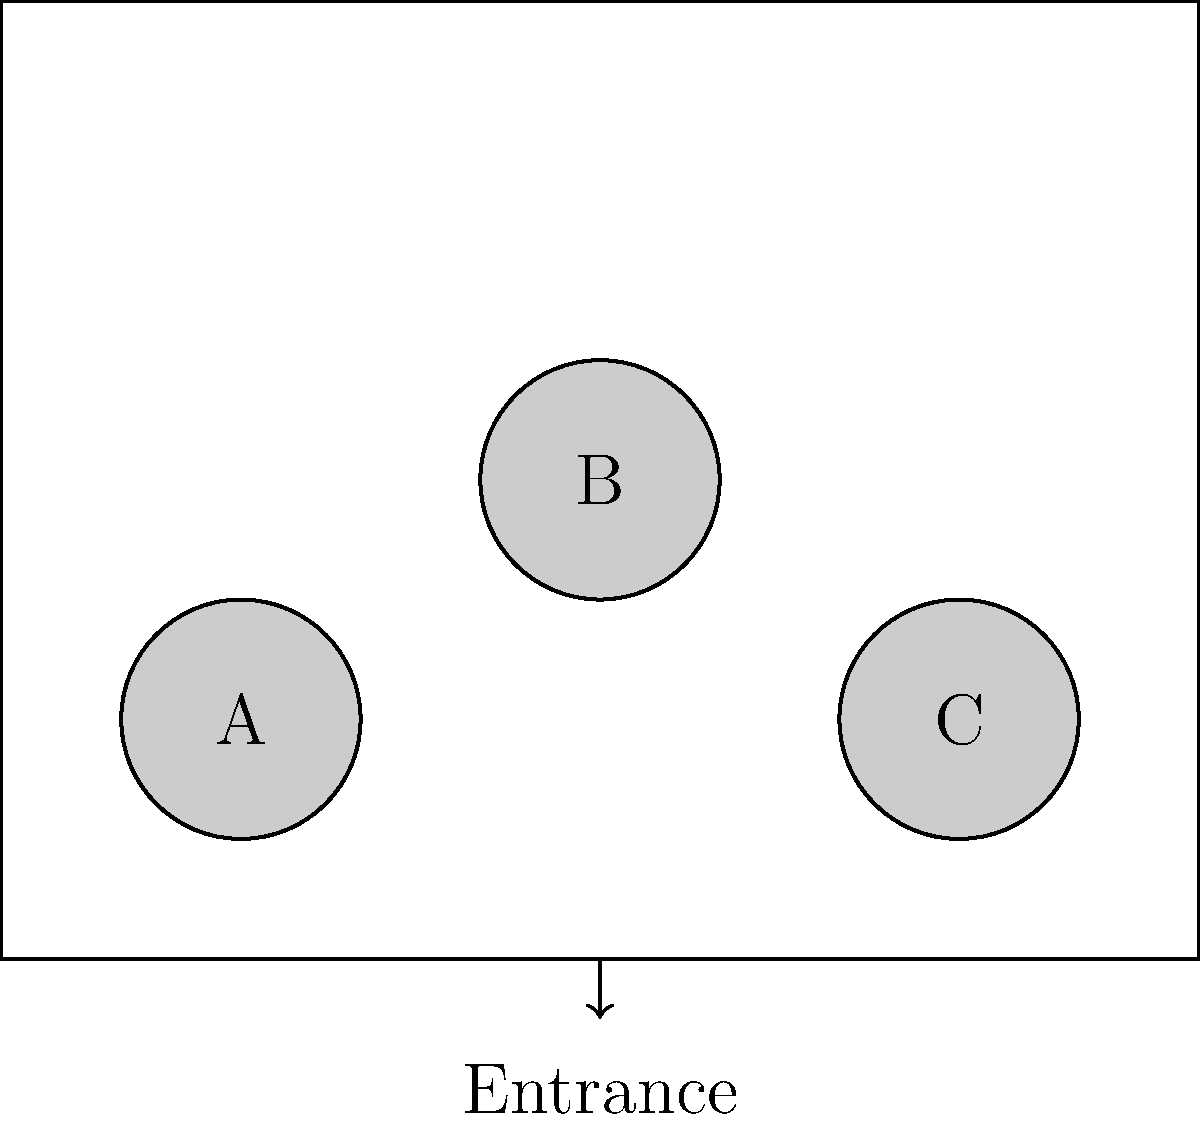You're organizing a community gathering in a rectangular room with three circular tables (A, B, and C) as shown in the floor plan. Each table can seat 8 people. If you want to maximize interaction between different groups and minimize walking distance from the entrance, which table should be assigned to the elderly attendees? To answer this question, we need to consider several factors:

1. Interaction between groups: The central table (B) allows for the most interaction as it's equidistant from the other two tables.

2. Walking distance from the entrance: 
   - Table A is approximately 5 units from the entrance
   - Table B is approximately 4 units from the entrance
   - Table C is approximately 5 units from the entrance

3. Accessibility for elderly attendees: The table closest to the entrance would be the most suitable for elderly attendees to minimize their walking distance.

4. Position in the room: Central positions are generally better for elderly attendees as they can observe and participate in activities more easily.

Considering all these factors:
- Table B is the closest to the entrance, reducing walking distance for elderly attendees.
- Table B is centrally located, allowing for better interaction and observation of activities.
- Table B provides the best balance between accessibility and interaction potential.

Therefore, Table B would be the optimal choice for elderly attendees.
Answer: Table B 